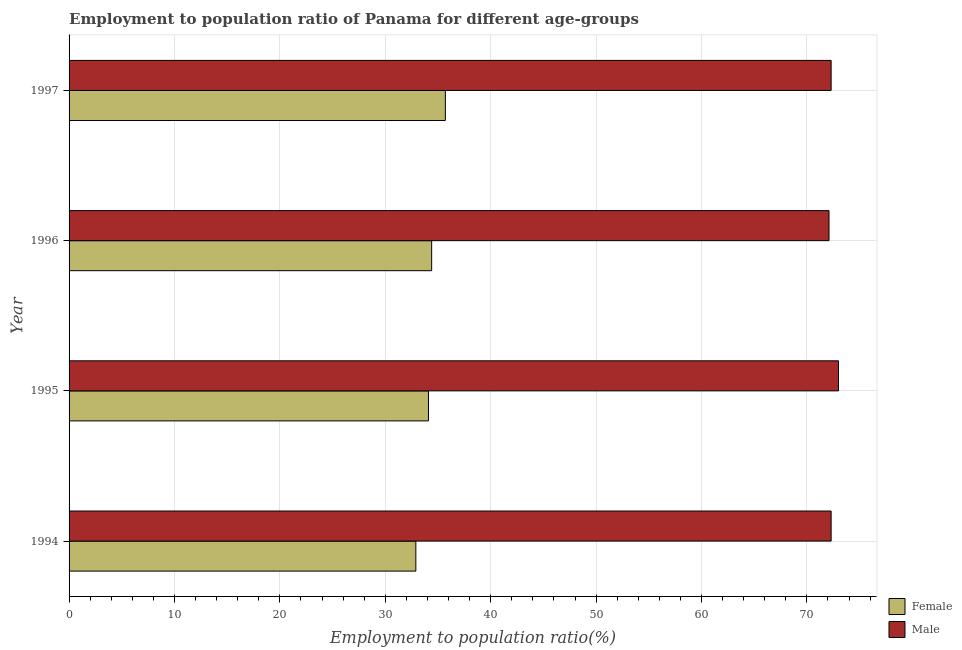How many groups of bars are there?
Your answer should be very brief. 4. Are the number of bars per tick equal to the number of legend labels?
Offer a very short reply. Yes. What is the employment to population ratio(female) in 1997?
Keep it short and to the point. 35.7. Across all years, what is the minimum employment to population ratio(male)?
Your answer should be very brief. 72.1. What is the total employment to population ratio(female) in the graph?
Provide a short and direct response. 137.1. What is the difference between the employment to population ratio(male) in 1997 and the employment to population ratio(female) in 1995?
Provide a short and direct response. 38.2. What is the average employment to population ratio(male) per year?
Your answer should be compact. 72.42. In the year 1994, what is the difference between the employment to population ratio(female) and employment to population ratio(male)?
Your response must be concise. -39.4. In how many years, is the employment to population ratio(male) greater than 68 %?
Give a very brief answer. 4. What is the ratio of the employment to population ratio(female) in 1996 to that in 1997?
Provide a short and direct response. 0.96. What is the difference between the highest and the second highest employment to population ratio(male)?
Offer a terse response. 0.7. What is the difference between the highest and the lowest employment to population ratio(male)?
Ensure brevity in your answer.  0.9. Is the sum of the employment to population ratio(male) in 1994 and 1996 greater than the maximum employment to population ratio(female) across all years?
Offer a terse response. Yes. How many bars are there?
Your answer should be compact. 8. Are all the bars in the graph horizontal?
Ensure brevity in your answer.  Yes. What is the difference between two consecutive major ticks on the X-axis?
Make the answer very short. 10. Are the values on the major ticks of X-axis written in scientific E-notation?
Your response must be concise. No. Does the graph contain any zero values?
Ensure brevity in your answer.  No. Where does the legend appear in the graph?
Provide a short and direct response. Bottom right. What is the title of the graph?
Your answer should be very brief. Employment to population ratio of Panama for different age-groups. Does "Manufacturing industries and construction" appear as one of the legend labels in the graph?
Make the answer very short. No. What is the label or title of the Y-axis?
Make the answer very short. Year. What is the Employment to population ratio(%) in Female in 1994?
Your response must be concise. 32.9. What is the Employment to population ratio(%) of Male in 1994?
Offer a very short reply. 72.3. What is the Employment to population ratio(%) in Female in 1995?
Give a very brief answer. 34.1. What is the Employment to population ratio(%) of Male in 1995?
Offer a very short reply. 73. What is the Employment to population ratio(%) of Female in 1996?
Offer a very short reply. 34.4. What is the Employment to population ratio(%) in Male in 1996?
Your response must be concise. 72.1. What is the Employment to population ratio(%) in Female in 1997?
Provide a succinct answer. 35.7. What is the Employment to population ratio(%) in Male in 1997?
Offer a very short reply. 72.3. Across all years, what is the maximum Employment to population ratio(%) in Female?
Keep it short and to the point. 35.7. Across all years, what is the minimum Employment to population ratio(%) of Female?
Offer a very short reply. 32.9. Across all years, what is the minimum Employment to population ratio(%) in Male?
Offer a very short reply. 72.1. What is the total Employment to population ratio(%) in Female in the graph?
Keep it short and to the point. 137.1. What is the total Employment to population ratio(%) in Male in the graph?
Your answer should be compact. 289.7. What is the difference between the Employment to population ratio(%) of Female in 1994 and that in 1995?
Keep it short and to the point. -1.2. What is the difference between the Employment to population ratio(%) of Female in 1994 and that in 1996?
Make the answer very short. -1.5. What is the difference between the Employment to population ratio(%) in Male in 1994 and that in 1996?
Your answer should be compact. 0.2. What is the difference between the Employment to population ratio(%) of Male in 1994 and that in 1997?
Provide a short and direct response. 0. What is the difference between the Employment to population ratio(%) in Female in 1995 and that in 1997?
Provide a short and direct response. -1.6. What is the difference between the Employment to population ratio(%) of Female in 1994 and the Employment to population ratio(%) of Male in 1995?
Keep it short and to the point. -40.1. What is the difference between the Employment to population ratio(%) of Female in 1994 and the Employment to population ratio(%) of Male in 1996?
Give a very brief answer. -39.2. What is the difference between the Employment to population ratio(%) of Female in 1994 and the Employment to population ratio(%) of Male in 1997?
Give a very brief answer. -39.4. What is the difference between the Employment to population ratio(%) in Female in 1995 and the Employment to population ratio(%) in Male in 1996?
Provide a succinct answer. -38. What is the difference between the Employment to population ratio(%) of Female in 1995 and the Employment to population ratio(%) of Male in 1997?
Give a very brief answer. -38.2. What is the difference between the Employment to population ratio(%) of Female in 1996 and the Employment to population ratio(%) of Male in 1997?
Keep it short and to the point. -37.9. What is the average Employment to population ratio(%) in Female per year?
Your answer should be compact. 34.27. What is the average Employment to population ratio(%) in Male per year?
Your response must be concise. 72.42. In the year 1994, what is the difference between the Employment to population ratio(%) of Female and Employment to population ratio(%) of Male?
Keep it short and to the point. -39.4. In the year 1995, what is the difference between the Employment to population ratio(%) of Female and Employment to population ratio(%) of Male?
Offer a very short reply. -38.9. In the year 1996, what is the difference between the Employment to population ratio(%) in Female and Employment to population ratio(%) in Male?
Keep it short and to the point. -37.7. In the year 1997, what is the difference between the Employment to population ratio(%) of Female and Employment to population ratio(%) of Male?
Provide a short and direct response. -36.6. What is the ratio of the Employment to population ratio(%) in Female in 1994 to that in 1995?
Your response must be concise. 0.96. What is the ratio of the Employment to population ratio(%) of Male in 1994 to that in 1995?
Offer a terse response. 0.99. What is the ratio of the Employment to population ratio(%) in Female in 1994 to that in 1996?
Your response must be concise. 0.96. What is the ratio of the Employment to population ratio(%) of Female in 1994 to that in 1997?
Keep it short and to the point. 0.92. What is the ratio of the Employment to population ratio(%) of Male in 1994 to that in 1997?
Give a very brief answer. 1. What is the ratio of the Employment to population ratio(%) in Male in 1995 to that in 1996?
Make the answer very short. 1.01. What is the ratio of the Employment to population ratio(%) of Female in 1995 to that in 1997?
Your answer should be compact. 0.96. What is the ratio of the Employment to population ratio(%) in Male in 1995 to that in 1997?
Make the answer very short. 1.01. What is the ratio of the Employment to population ratio(%) in Female in 1996 to that in 1997?
Your response must be concise. 0.96. What is the ratio of the Employment to population ratio(%) of Male in 1996 to that in 1997?
Keep it short and to the point. 1. What is the difference between the highest and the lowest Employment to population ratio(%) of Female?
Offer a very short reply. 2.8. 